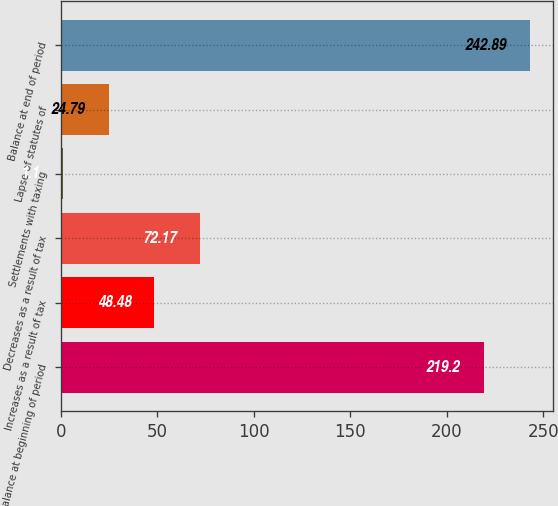<chart> <loc_0><loc_0><loc_500><loc_500><bar_chart><fcel>Balance at beginning of period<fcel>Increases as a result of tax<fcel>Decreases as a result of tax<fcel>Settlements with taxing<fcel>Lapse of statutes of<fcel>Balance at end of period<nl><fcel>219.2<fcel>48.48<fcel>72.17<fcel>1.1<fcel>24.79<fcel>242.89<nl></chart> 